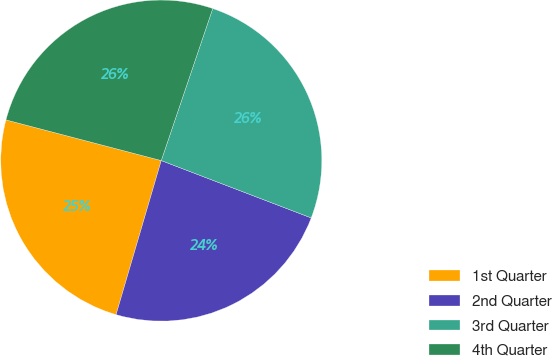Convert chart. <chart><loc_0><loc_0><loc_500><loc_500><pie_chart><fcel>1st Quarter<fcel>2nd Quarter<fcel>3rd Quarter<fcel>4th Quarter<nl><fcel>24.54%<fcel>23.73%<fcel>25.62%<fcel>26.12%<nl></chart> 